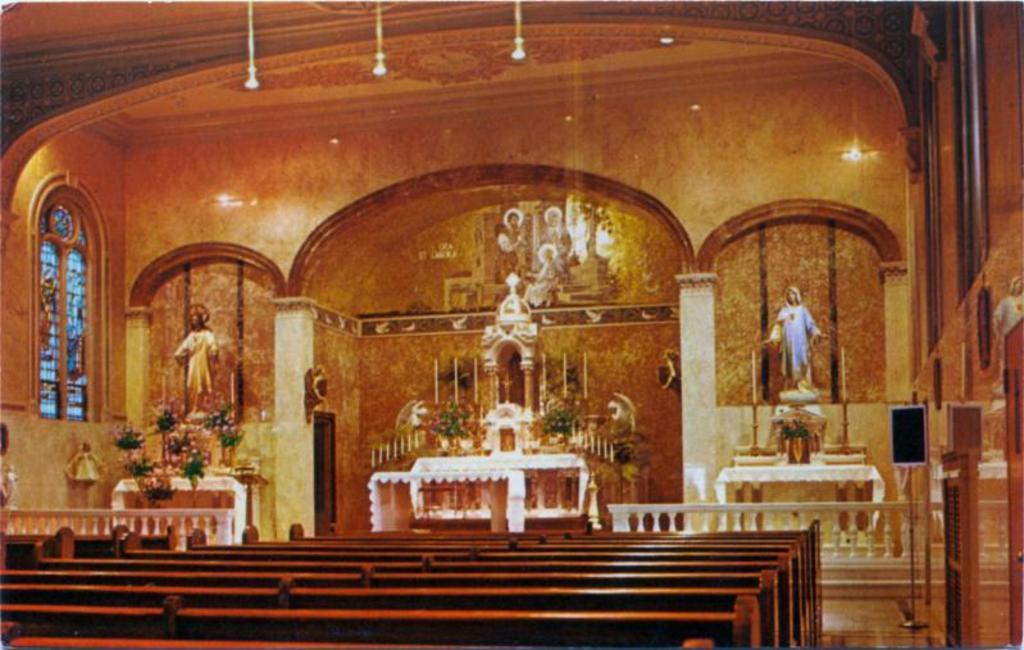Can you describe this image briefly? This is inside a church. There are benches. On the table there are flower bouquets. Also there are statues, candles, lights and windows. 